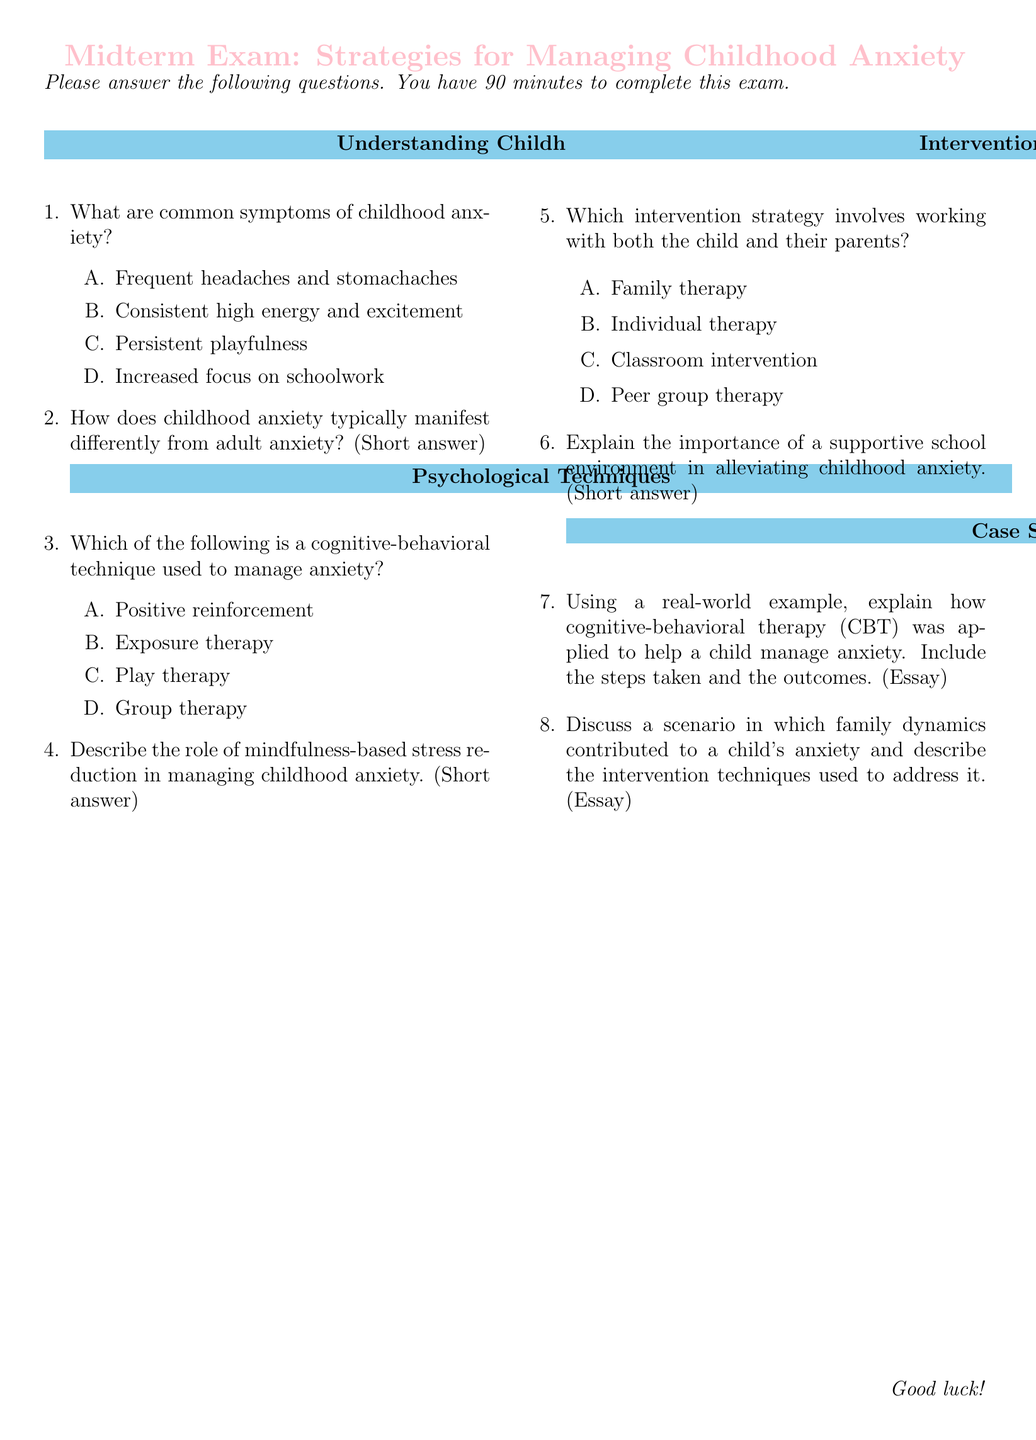What are common symptoms of childhood anxiety? The document lists options for common symptoms, which include physical complaints like headaches and emotional states but does not provide a specific number of symptoms.
Answer: Frequent headaches and stomachaches Which cognitive-behavioral technique is used to manage anxiety? The document presents multiple choice options for cognitive-behavioral techniques, highlighting one as the correct answer.
Answer: Exposure therapy What intervention strategy involves working with both the child and their parents? The document specifies intervention strategies that include options for therapy types, one of which involves parents.
Answer: Family therapy What is the total time allowed for the exam? The document states that there is a specific time frame given for the completion of the exam.
Answer: 90 minutes Explain the role of mindfulness-based stress reduction. The document mentions this topic in relation to childhood anxiety and asks for a short answer but does not provide details.
Answer: (Open-ended response expected) What section title follows "Understanding Childhood Anxiety"? The document is structured in sections, and one of these follows directly after the first specified one.
Answer: Psychological Techniques Number of case study questions in the exam? The document outlines the types of questions and specifies the number related to case studies.
Answer: 2 What color is used for the section titles? The document indicates that a specific color is used to signify section titles throughout.
Answer: childblue 